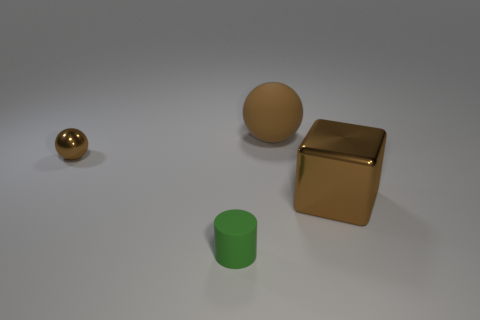Add 1 large matte objects. How many objects exist? 5 Subtract all cubes. How many objects are left? 3 Add 2 cylinders. How many cylinders are left? 3 Add 3 gray rubber blocks. How many gray rubber blocks exist? 3 Subtract 0 green blocks. How many objects are left? 4 Subtract all tiny green metallic spheres. Subtract all small brown shiny spheres. How many objects are left? 3 